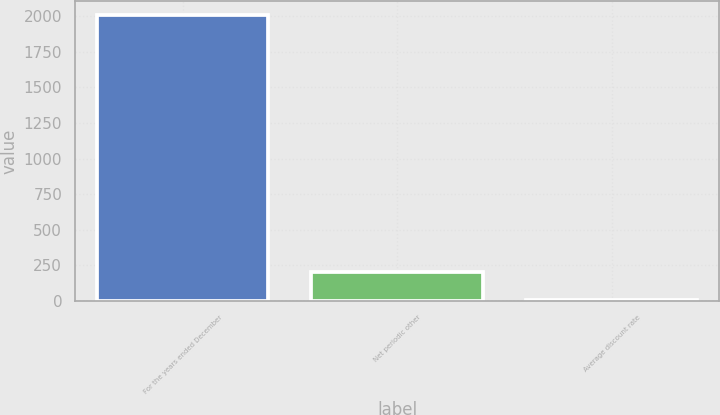Convert chart. <chart><loc_0><loc_0><loc_500><loc_500><bar_chart><fcel>For the years ended December<fcel>Net periodic other<fcel>Average discount rate<nl><fcel>2007<fcel>205.92<fcel>5.8<nl></chart> 